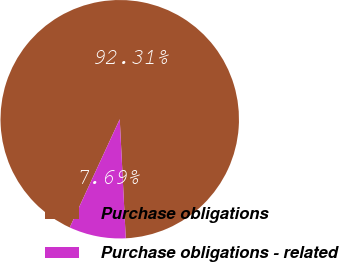<chart> <loc_0><loc_0><loc_500><loc_500><pie_chart><fcel>Purchase obligations<fcel>Purchase obligations - related<nl><fcel>92.31%<fcel>7.69%<nl></chart> 